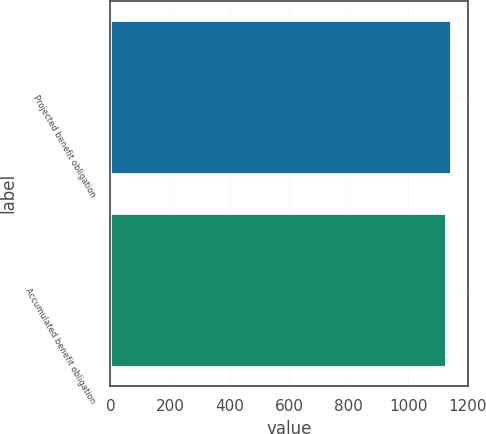Convert chart. <chart><loc_0><loc_0><loc_500><loc_500><bar_chart><fcel>Projected benefit obligation<fcel>Accumulated benefit obligation<nl><fcel>1144<fcel>1126<nl></chart> 